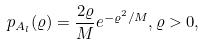<formula> <loc_0><loc_0><loc_500><loc_500>p _ { A _ { l } } ( \varrho ) = \frac { 2 \varrho } { M } e ^ { - \varrho ^ { 2 } / M } , \varrho > 0 ,</formula> 